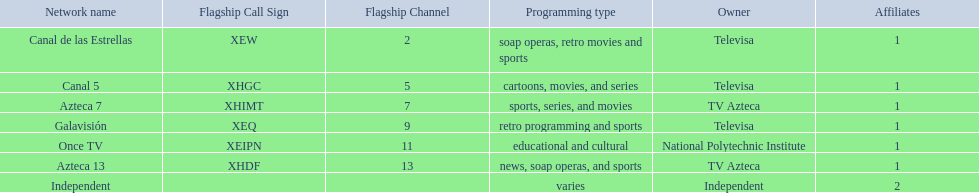Who are the owners of the stations listed here? Televisa, Televisa, TV Azteca, Televisa, National Polytechnic Institute, TV Azteca, Independent. What is the one station owned by national polytechnic institute? Once TV. 